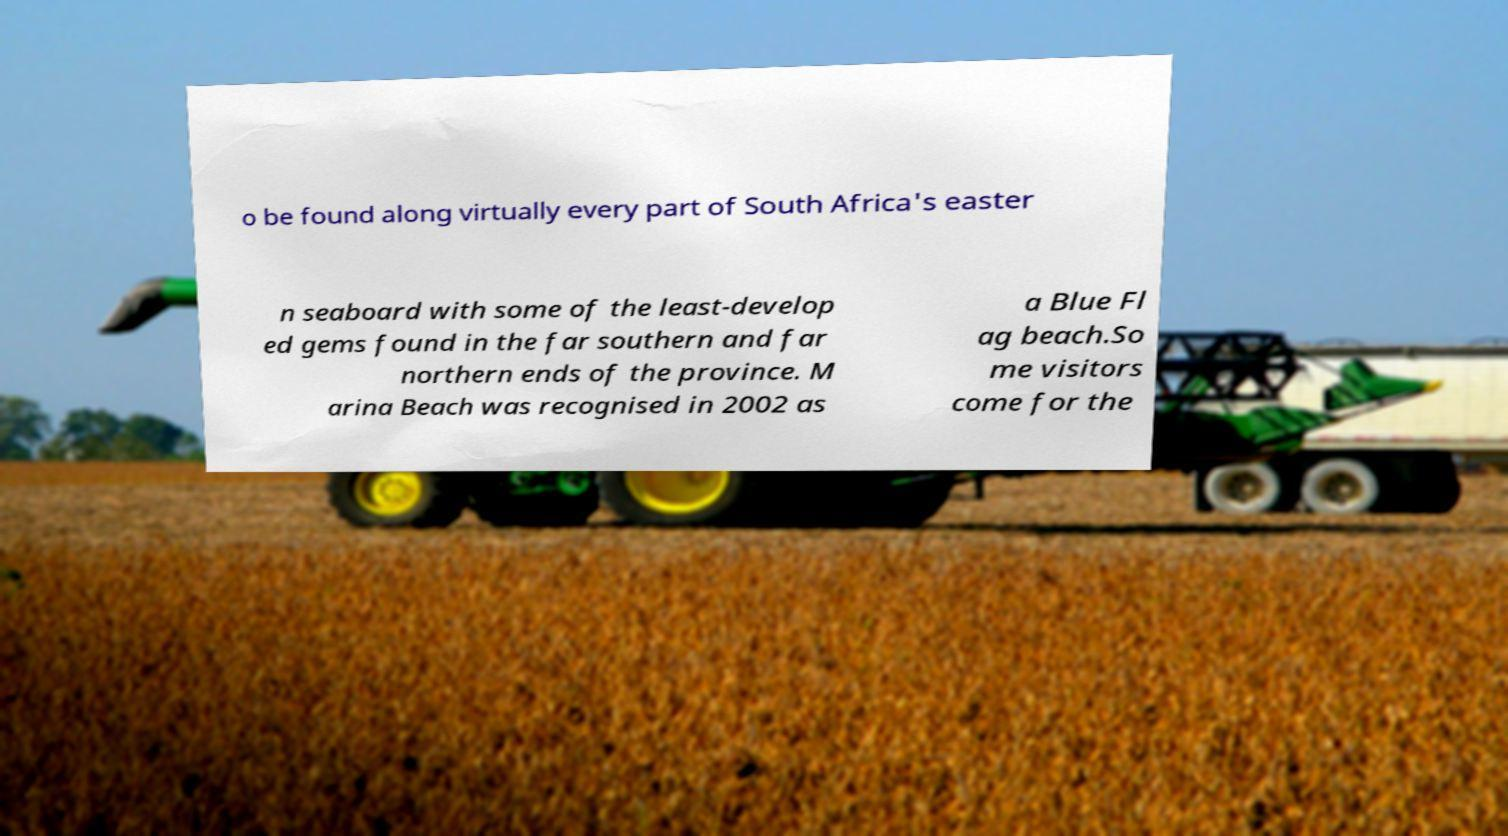Can you accurately transcribe the text from the provided image for me? o be found along virtually every part of South Africa's easter n seaboard with some of the least-develop ed gems found in the far southern and far northern ends of the province. M arina Beach was recognised in 2002 as a Blue Fl ag beach.So me visitors come for the 